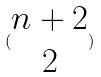Convert formula to latex. <formula><loc_0><loc_0><loc_500><loc_500>( \begin{matrix} n + 2 \\ 2 \end{matrix} )</formula> 